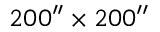<formula> <loc_0><loc_0><loc_500><loc_500>2 0 0 ^ { \prime \prime } \times 2 0 0 ^ { \prime \prime }</formula> 